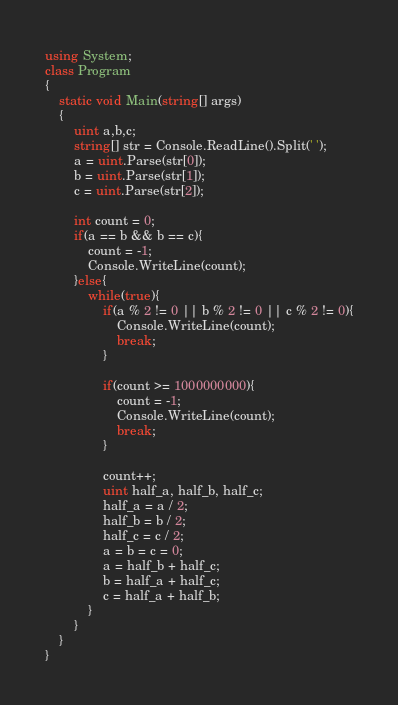<code> <loc_0><loc_0><loc_500><loc_500><_C#_>using System;
class Program
{
    static void Main(string[] args)
    {
        uint a,b,c;
        string[] str = Console.ReadLine().Split(' ');
        a = uint.Parse(str[0]);
        b = uint.Parse(str[1]);
        c = uint.Parse(str[2]);
        
        int count = 0;
        if(a == b && b == c){
            count = -1;
            Console.WriteLine(count);
        }else{
            while(true){
                if(a % 2 != 0 || b % 2 != 0 || c % 2 != 0){
                    Console.WriteLine(count);
                    break;
                }

                if(count >= 1000000000){
                    count = -1;
                    Console.WriteLine(count);
                    break;
                }

                count++;
                uint half_a, half_b, half_c;
                half_a = a / 2;
                half_b = b / 2;
                half_c = c / 2;
                a = b = c = 0;
                a = half_b + half_c;
                b = half_a + half_c;
                c = half_a + half_b;
            }
        }
    }
}</code> 